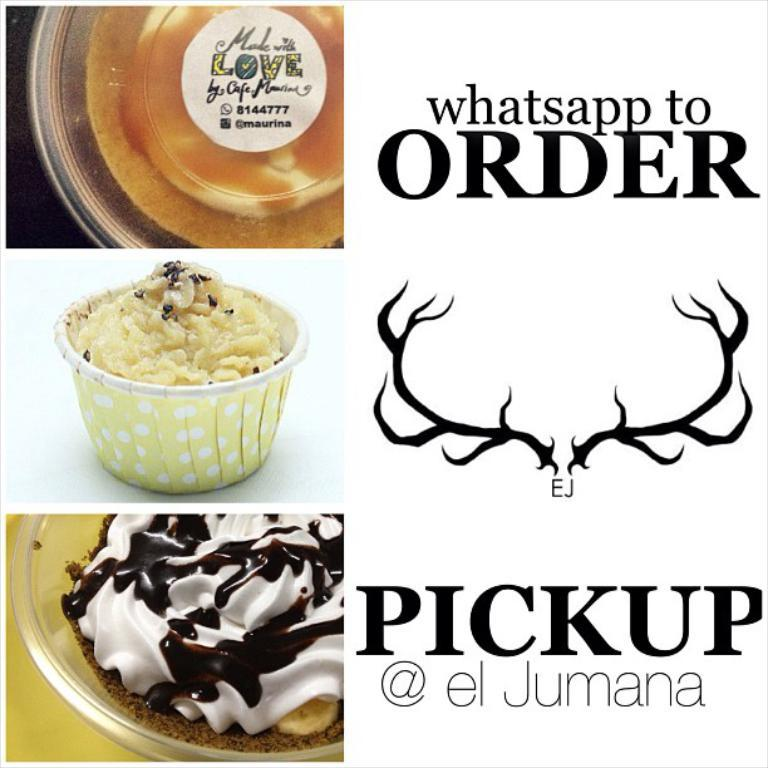What is featured on the poster in the image? There is a poster with writing in the image, and it also has a logo. What can be seen on the left side of the image? There are images of food items on bowls on the left side of the image. What type of cork can be seen in the image? There is no cork present in the image. How does the process of making the food items on the poster relate to the uncle's cooking skills? There is no uncle or cooking process mentioned in the image, so this question cannot be answered definitively. 